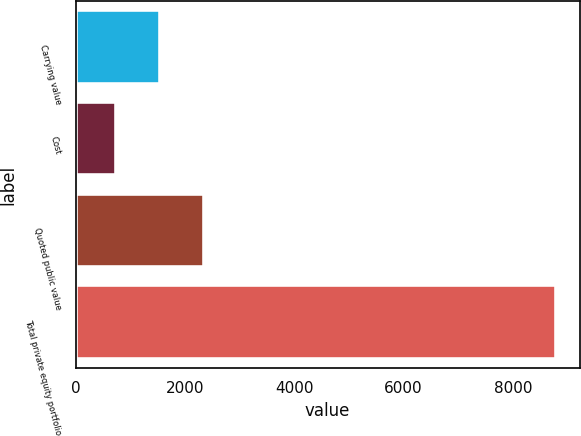Convert chart to OTSL. <chart><loc_0><loc_0><loc_500><loc_500><bar_chart><fcel>Carrying value<fcel>Cost<fcel>Quoted public value<fcel>Total private equity portfolio<nl><fcel>1546.8<fcel>743<fcel>2350.6<fcel>8781<nl></chart> 